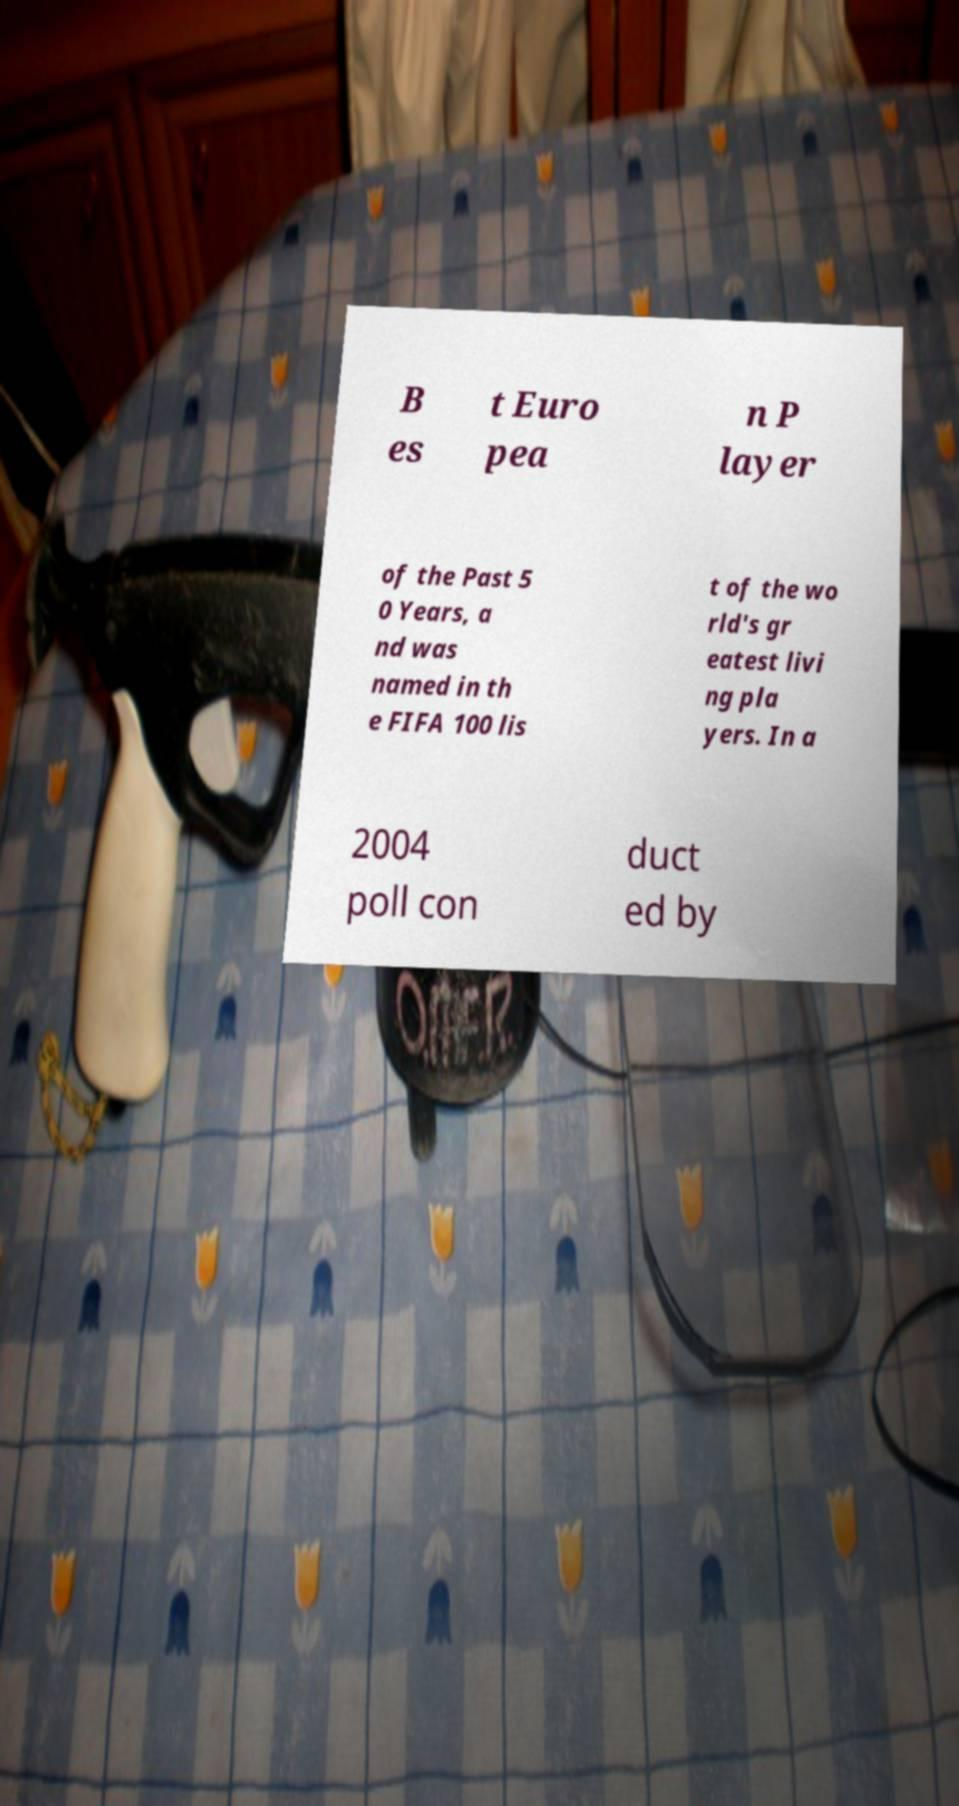Could you assist in decoding the text presented in this image and type it out clearly? B es t Euro pea n P layer of the Past 5 0 Years, a nd was named in th e FIFA 100 lis t of the wo rld's gr eatest livi ng pla yers. In a 2004 poll con duct ed by 